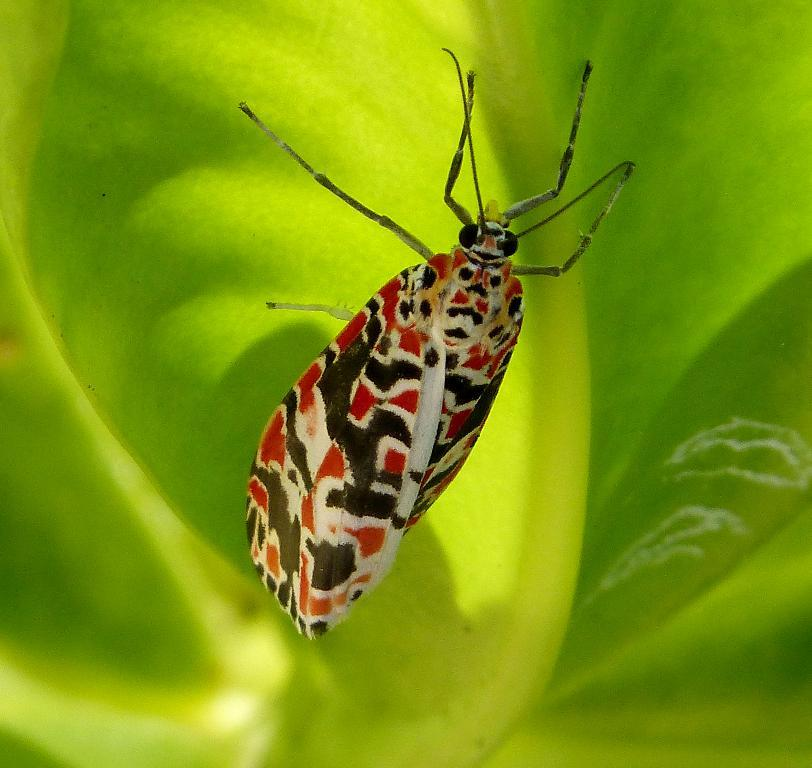What type of creature is in the image? There is an insect in the image. Where is the insect located? The insect is on a plant. How many friends are sitting on the furniture in the image? There is no furniture present in the image, and therefore no friends sitting on it. 